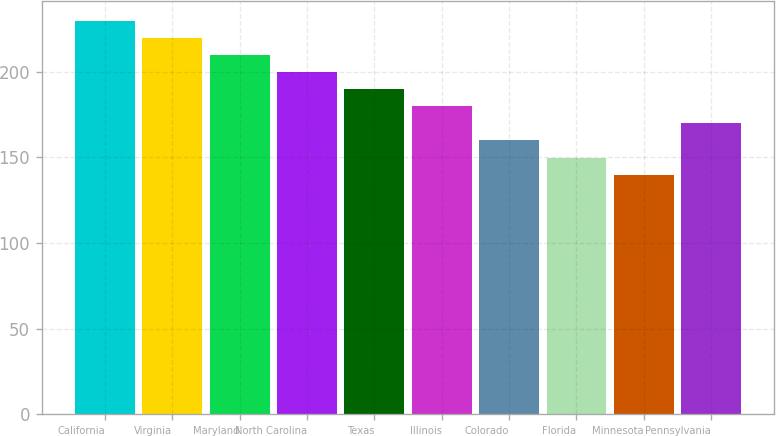<chart> <loc_0><loc_0><loc_500><loc_500><bar_chart><fcel>California<fcel>Virginia<fcel>Maryland<fcel>North Carolina<fcel>Texas<fcel>Illinois<fcel>Colorado<fcel>Florida<fcel>Minnesota<fcel>Pennsylvania<nl><fcel>229.74<fcel>219.76<fcel>209.78<fcel>199.8<fcel>189.82<fcel>179.84<fcel>159.88<fcel>149.9<fcel>139.92<fcel>169.86<nl></chart> 